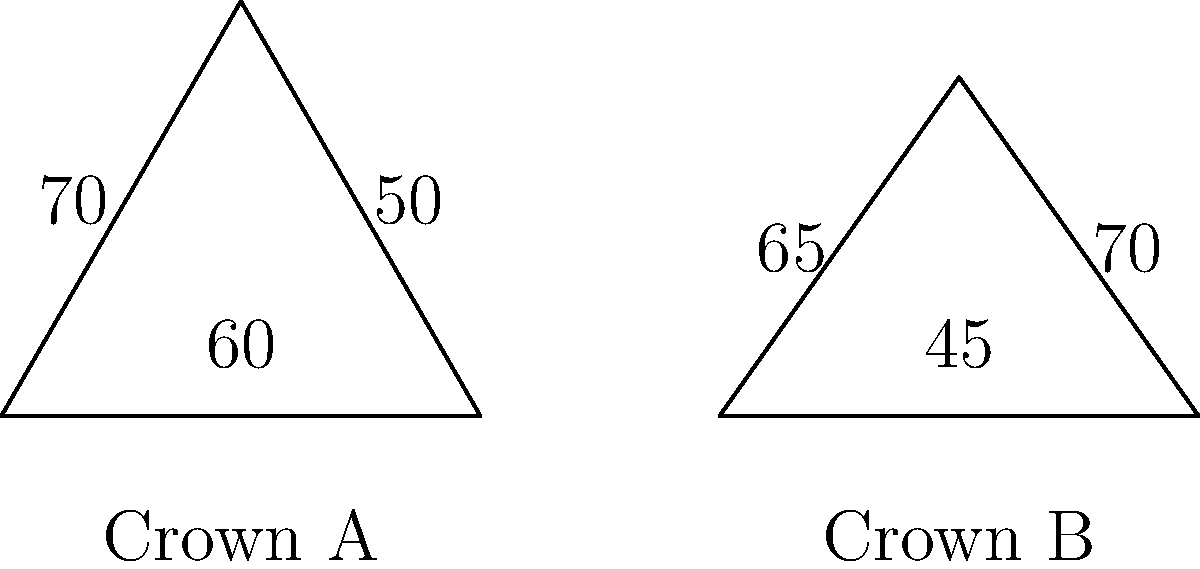Compare the angles in the crowns of two Swedish monarchs: Crown A from the 17th century and Crown B from the 19th century. What is the difference between the largest angles in each crown? To solve this problem, we need to follow these steps:

1. Identify the largest angle in Crown A:
   Crown A has angles of $60°$, $70°$, and $50°$.
   The largest angle in Crown A is $70°$.

2. Identify the largest angle in Crown B:
   Crown B has angles of $45°$, $65°$, and $70°$.
   The largest angle in Crown B is $70°$.

3. Calculate the difference between the largest angles:
   $70° - 70° = 0°$

The difference between the largest angles in each crown is $0°$, meaning they have the same largest angle.

This comparison reflects how crown designs evolved over time while maintaining certain angular features, which is an interesting aspect of Swedish royal history.
Answer: $0°$ 